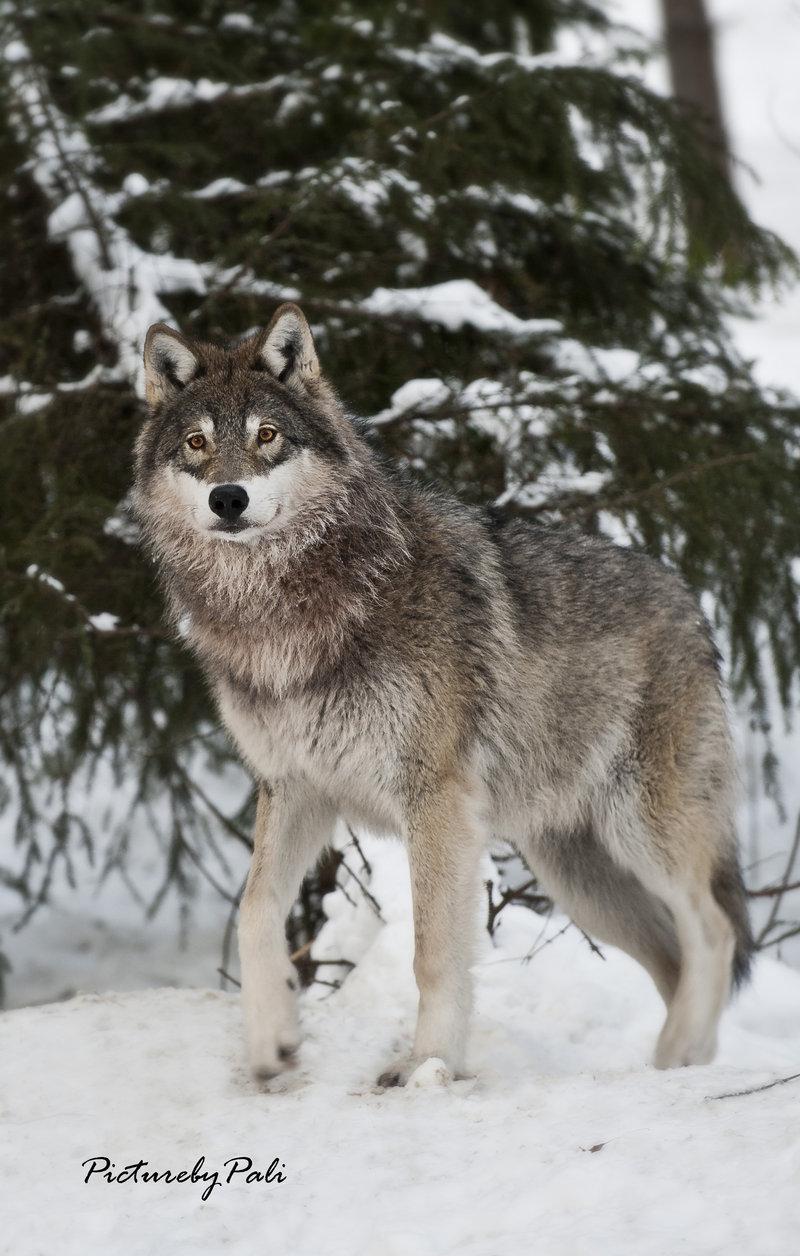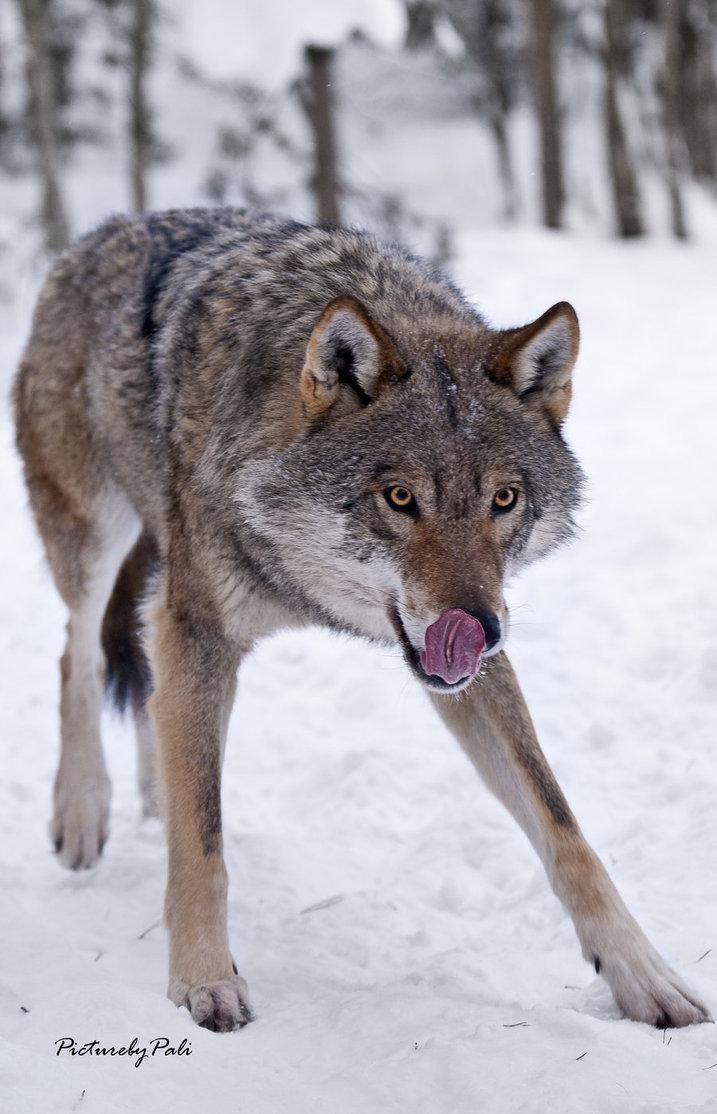The first image is the image on the left, the second image is the image on the right. Evaluate the accuracy of this statement regarding the images: "There are two wolves". Is it true? Answer yes or no. Yes. The first image is the image on the left, the second image is the image on the right. Given the left and right images, does the statement "The right image contains at least four wolves positioned close together in a snow-covered scene." hold true? Answer yes or no. No. 